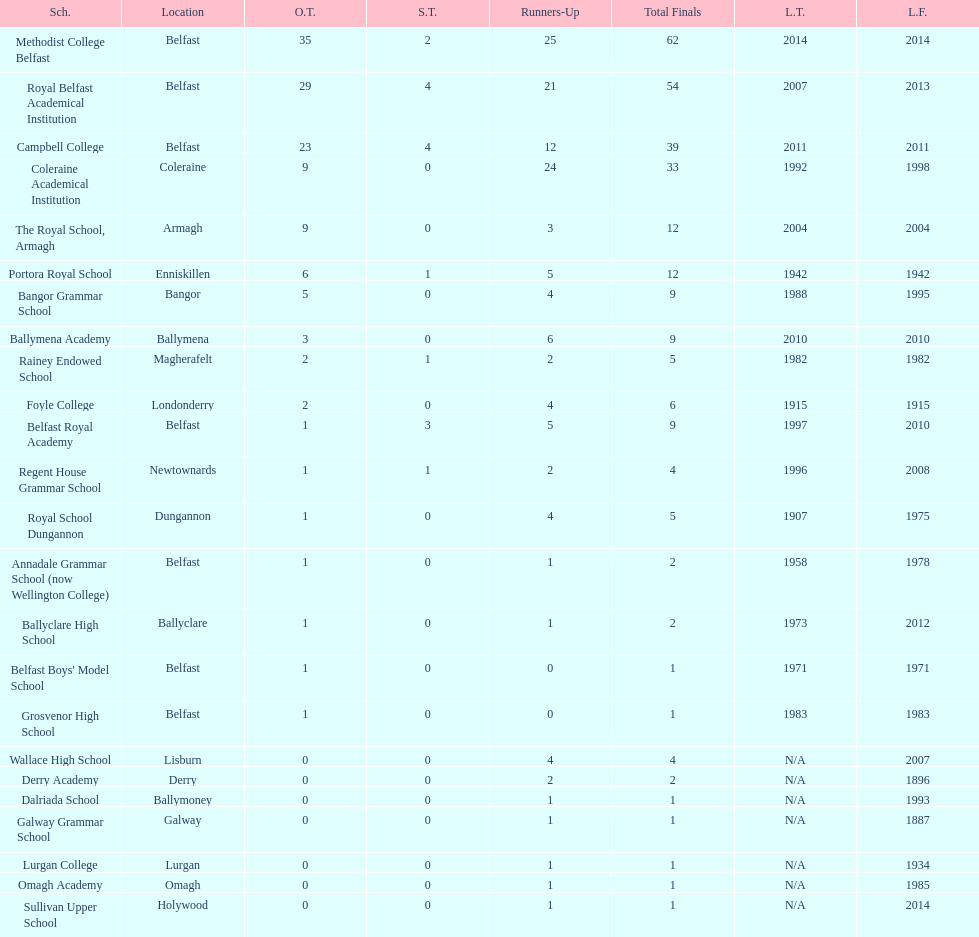What was the last year that the regent house grammar school won a title? 1996. Parse the full table. {'header': ['Sch.', 'Location', 'O.T.', 'S.T.', 'Runners-Up', 'Total Finals', 'L.T.', 'L.F.'], 'rows': [['Methodist College Belfast', 'Belfast', '35', '2', '25', '62', '2014', '2014'], ['Royal Belfast Academical Institution', 'Belfast', '29', '4', '21', '54', '2007', '2013'], ['Campbell College', 'Belfast', '23', '4', '12', '39', '2011', '2011'], ['Coleraine Academical Institution', 'Coleraine', '9', '0', '24', '33', '1992', '1998'], ['The Royal School, Armagh', 'Armagh', '9', '0', '3', '12', '2004', '2004'], ['Portora Royal School', 'Enniskillen', '6', '1', '5', '12', '1942', '1942'], ['Bangor Grammar School', 'Bangor', '5', '0', '4', '9', '1988', '1995'], ['Ballymena Academy', 'Ballymena', '3', '0', '6', '9', '2010', '2010'], ['Rainey Endowed School', 'Magherafelt', '2', '1', '2', '5', '1982', '1982'], ['Foyle College', 'Londonderry', '2', '0', '4', '6', '1915', '1915'], ['Belfast Royal Academy', 'Belfast', '1', '3', '5', '9', '1997', '2010'], ['Regent House Grammar School', 'Newtownards', '1', '1', '2', '4', '1996', '2008'], ['Royal School Dungannon', 'Dungannon', '1', '0', '4', '5', '1907', '1975'], ['Annadale Grammar School (now Wellington College)', 'Belfast', '1', '0', '1', '2', '1958', '1978'], ['Ballyclare High School', 'Ballyclare', '1', '0', '1', '2', '1973', '2012'], ["Belfast Boys' Model School", 'Belfast', '1', '0', '0', '1', '1971', '1971'], ['Grosvenor High School', 'Belfast', '1', '0', '0', '1', '1983', '1983'], ['Wallace High School', 'Lisburn', '0', '0', '4', '4', 'N/A', '2007'], ['Derry Academy', 'Derry', '0', '0', '2', '2', 'N/A', '1896'], ['Dalriada School', 'Ballymoney', '0', '0', '1', '1', 'N/A', '1993'], ['Galway Grammar School', 'Galway', '0', '0', '1', '1', 'N/A', '1887'], ['Lurgan College', 'Lurgan', '0', '0', '1', '1', 'N/A', '1934'], ['Omagh Academy', 'Omagh', '0', '0', '1', '1', 'N/A', '1985'], ['Sullivan Upper School', 'Holywood', '0', '0', '1', '1', 'N/A', '2014']]} 